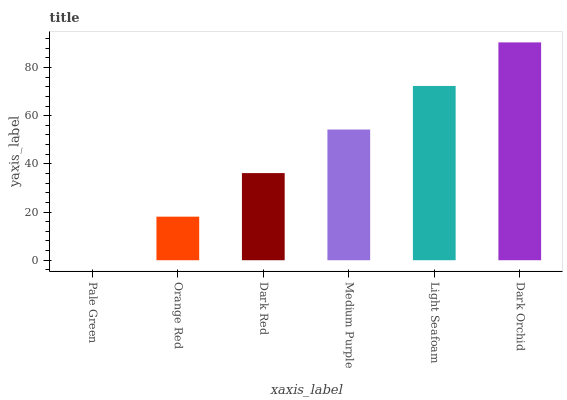Is Pale Green the minimum?
Answer yes or no. Yes. Is Dark Orchid the maximum?
Answer yes or no. Yes. Is Orange Red the minimum?
Answer yes or no. No. Is Orange Red the maximum?
Answer yes or no. No. Is Orange Red greater than Pale Green?
Answer yes or no. Yes. Is Pale Green less than Orange Red?
Answer yes or no. Yes. Is Pale Green greater than Orange Red?
Answer yes or no. No. Is Orange Red less than Pale Green?
Answer yes or no. No. Is Medium Purple the high median?
Answer yes or no. Yes. Is Dark Red the low median?
Answer yes or no. Yes. Is Dark Red the high median?
Answer yes or no. No. Is Orange Red the low median?
Answer yes or no. No. 